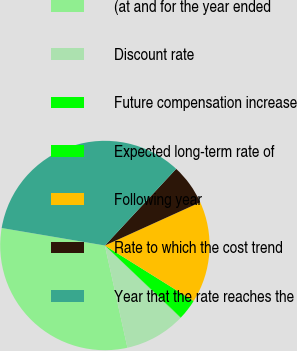Convert chart. <chart><loc_0><loc_0><loc_500><loc_500><pie_chart><fcel>(at and for the year ended<fcel>Discount rate<fcel>Future compensation increase<fcel>Expected long-term rate of<fcel>Following year<fcel>Rate to which the cost trend<fcel>Year that the rate reaches the<nl><fcel>31.13%<fcel>9.42%<fcel>0.06%<fcel>3.18%<fcel>15.66%<fcel>6.3%<fcel>34.25%<nl></chart> 